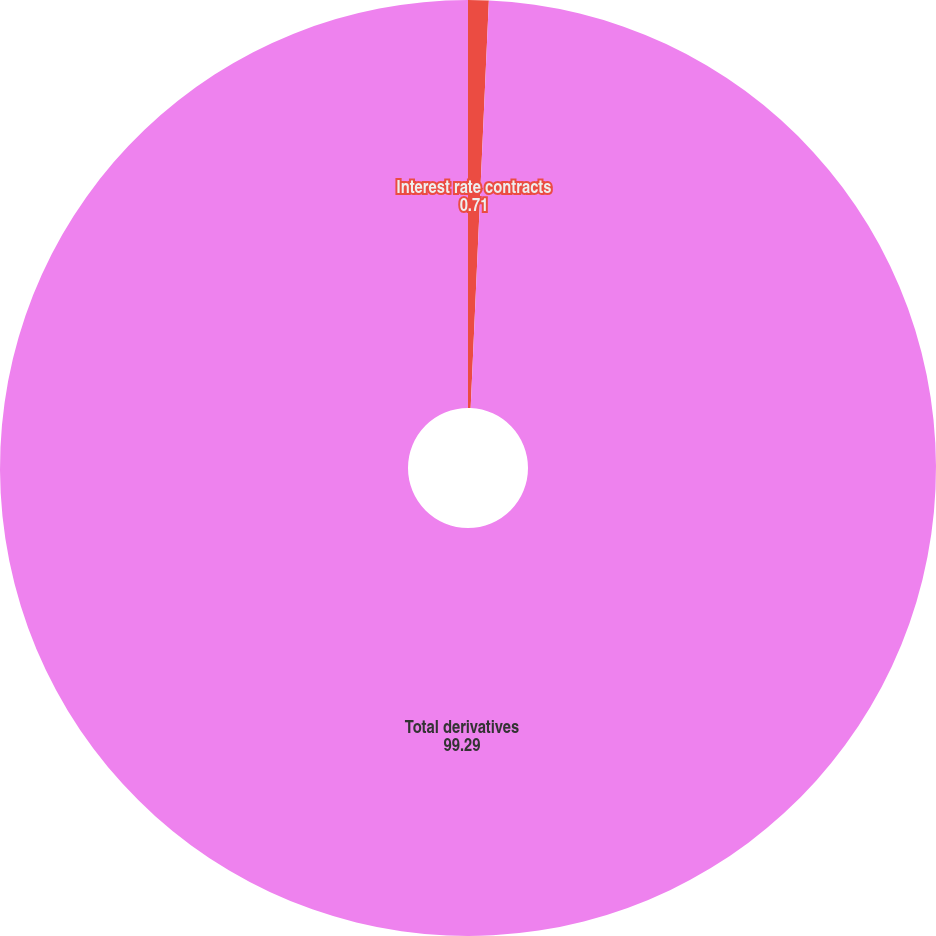<chart> <loc_0><loc_0><loc_500><loc_500><pie_chart><fcel>Interest rate contracts<fcel>Total derivatives<nl><fcel>0.71%<fcel>99.29%<nl></chart> 